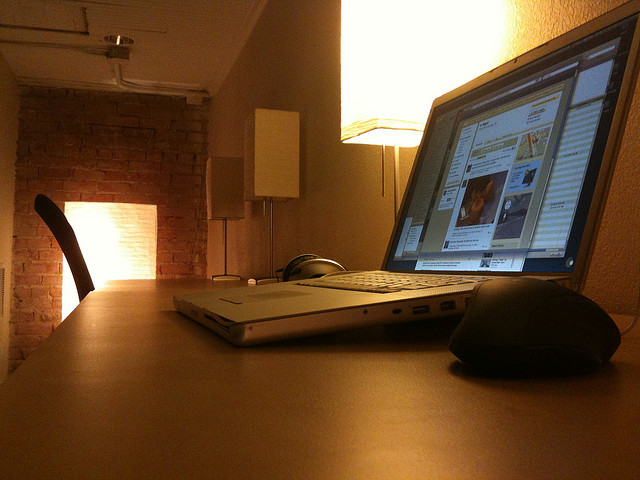<image>What brand of mouse is on the desk? I'm not sure what brand the mouse on the desk is. It could be Apple, Dell, Acer, or Logitech. What brand of mouse is on the desk? I don't know what brand of mouse is on the desk. It can be 'apple', 'dell', 'acer', or 'logitech'. 